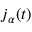Convert formula to latex. <formula><loc_0><loc_0><loc_500><loc_500>{ j } _ { \alpha } ( t )</formula> 